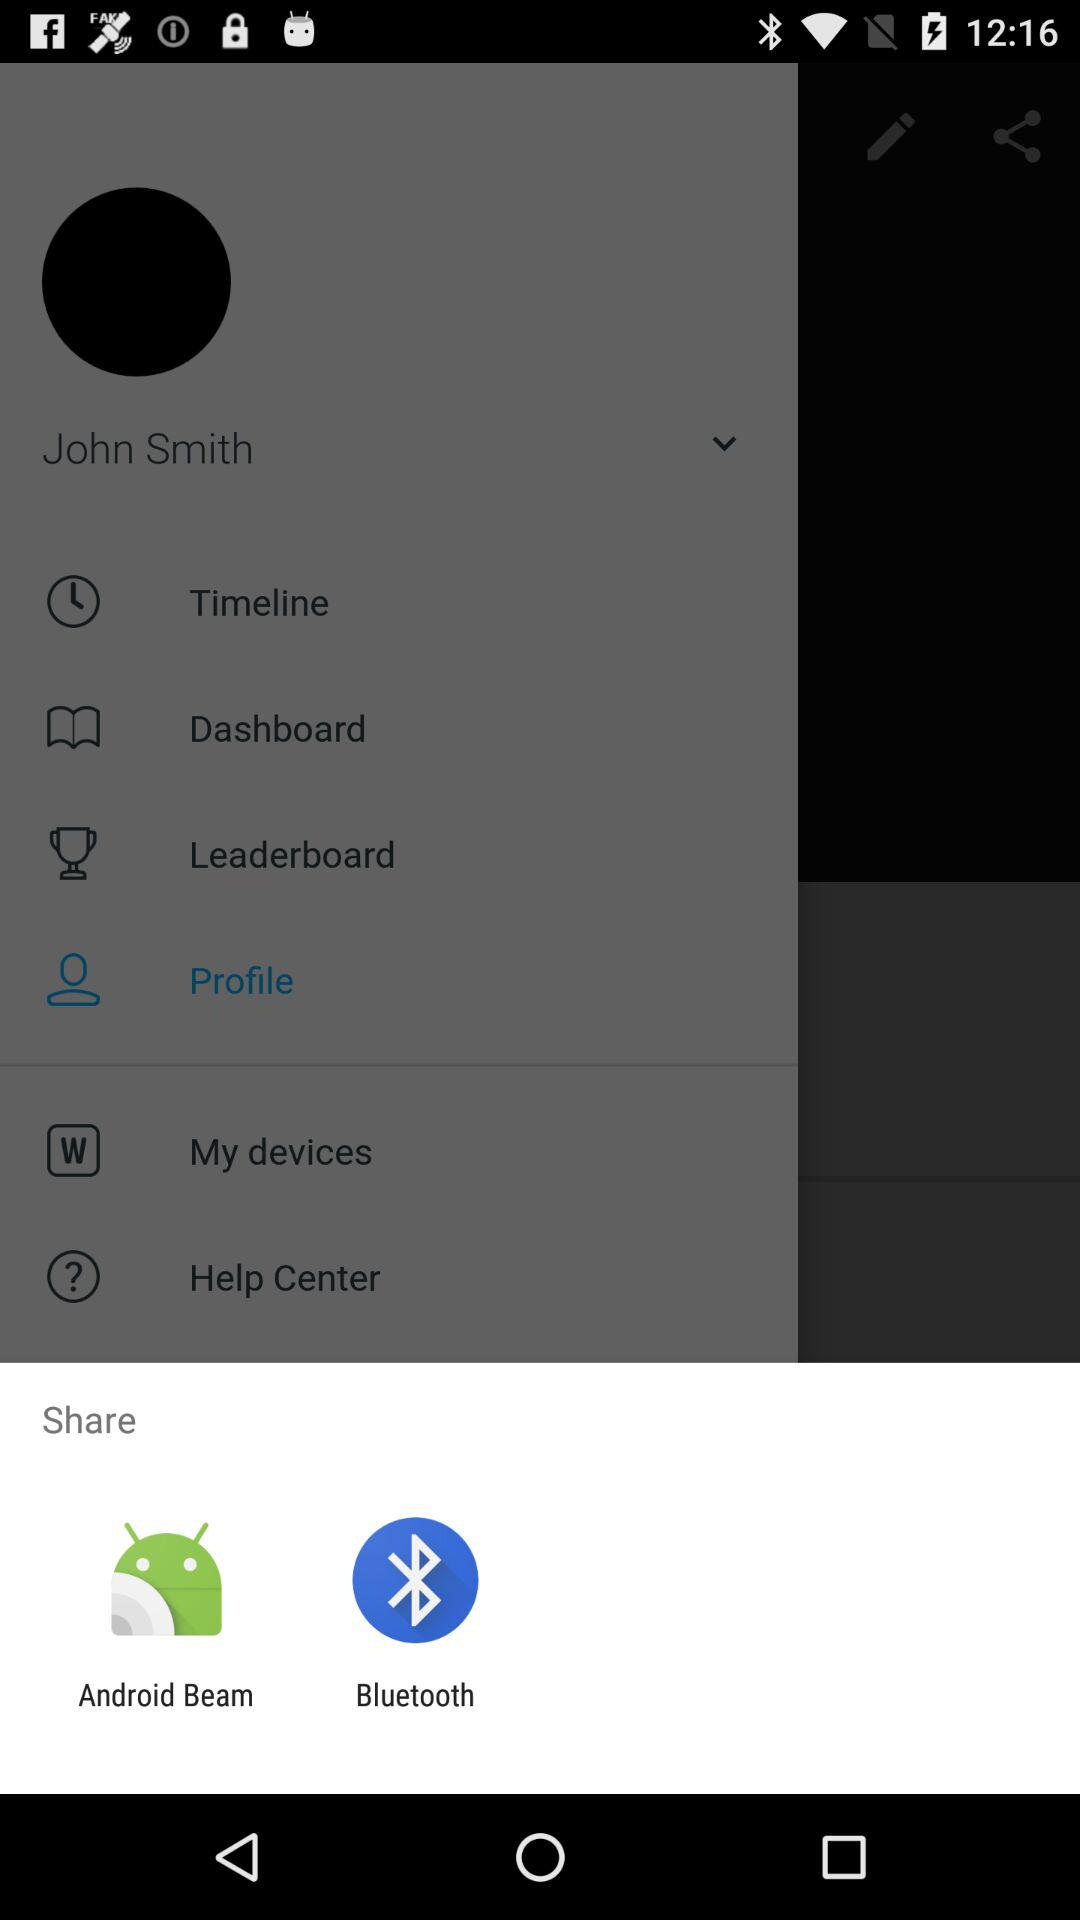Through which application can the content be shared? The content can be shared through "Android Beam" and "Bluetooth". 